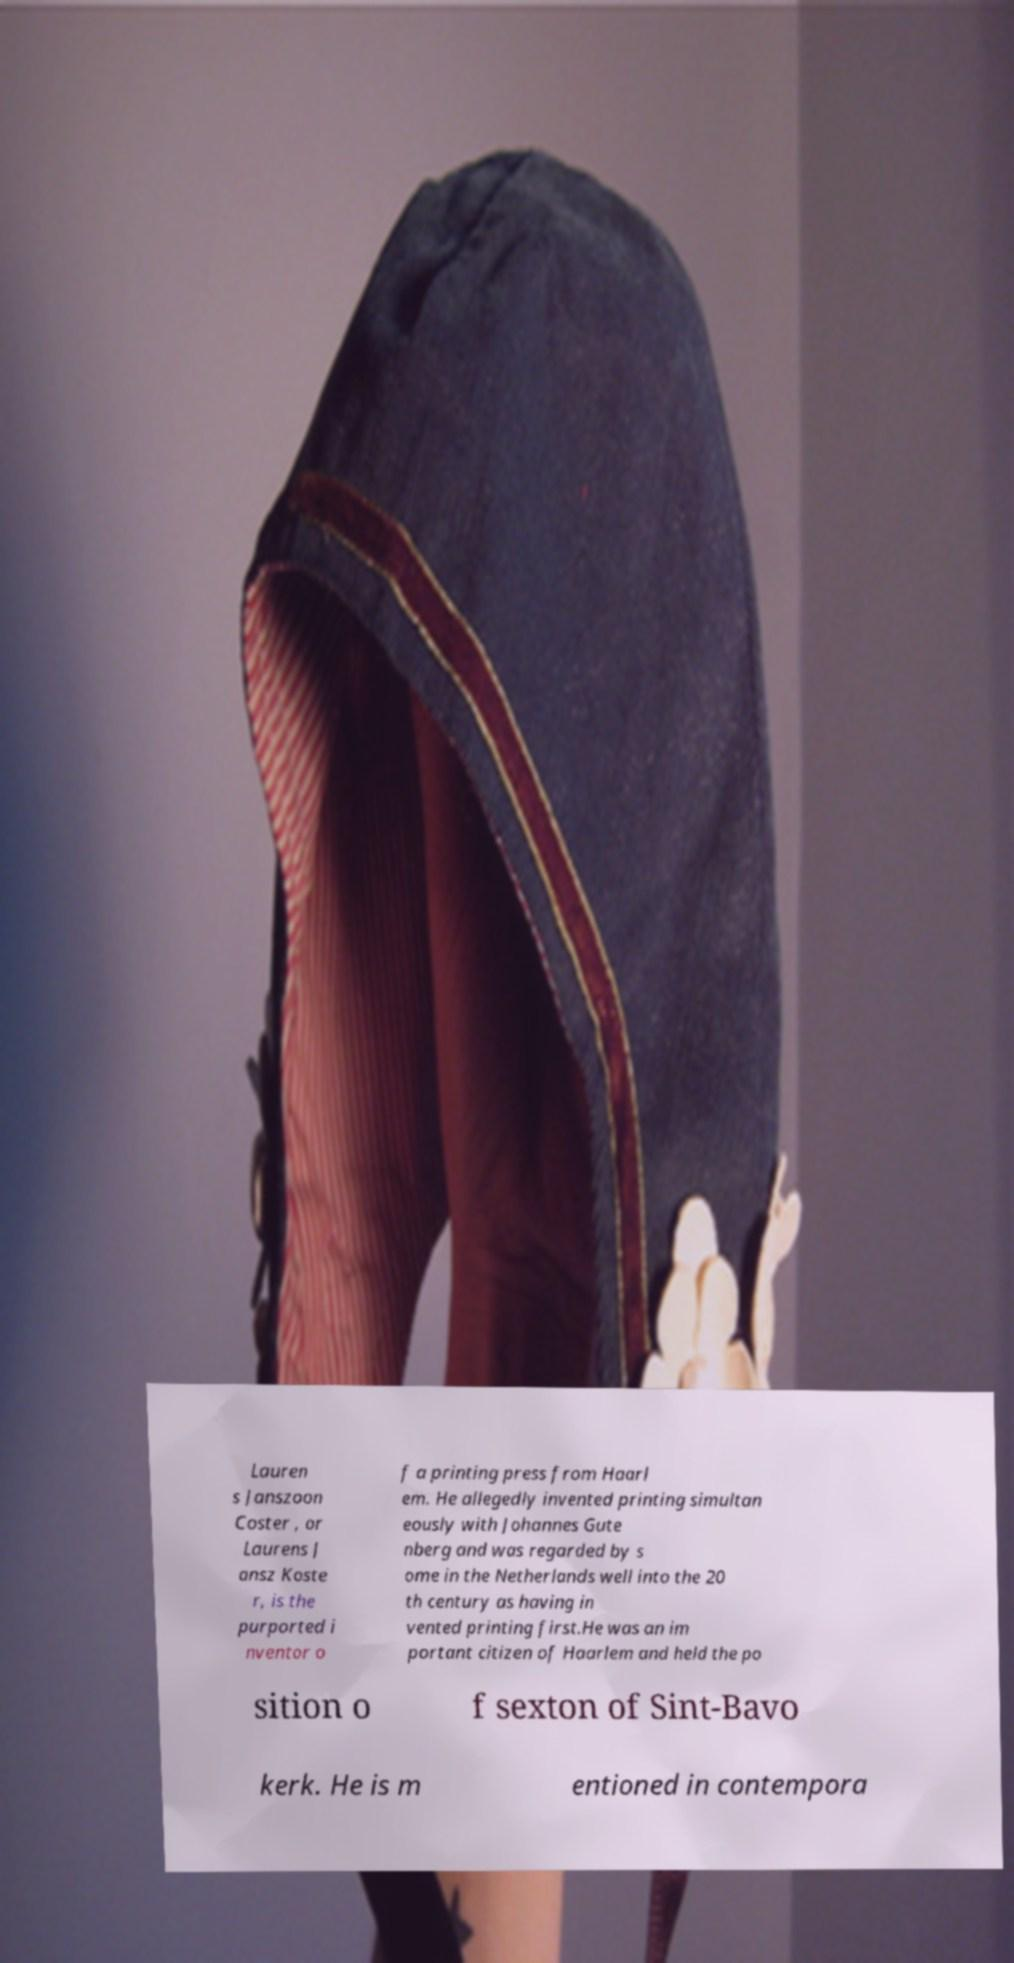I need the written content from this picture converted into text. Can you do that? Lauren s Janszoon Coster , or Laurens J ansz Koste r, is the purported i nventor o f a printing press from Haarl em. He allegedly invented printing simultan eously with Johannes Gute nberg and was regarded by s ome in the Netherlands well into the 20 th century as having in vented printing first.He was an im portant citizen of Haarlem and held the po sition o f sexton of Sint-Bavo kerk. He is m entioned in contempora 